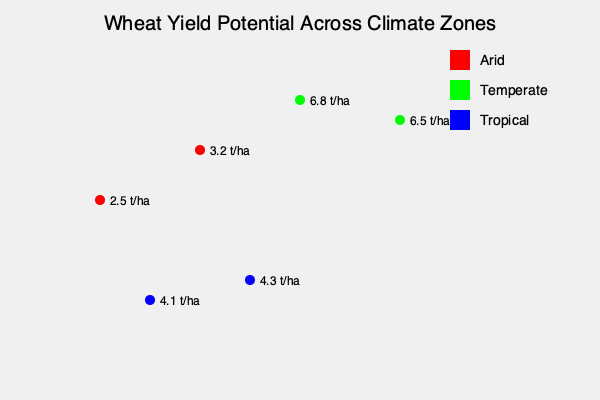Based on the map showing wheat yield potential across different climate zones, which climate zone demonstrates the highest average yield potential, and what factors might contribute to this difference? To answer this question, we need to follow these steps:

1. Identify the climate zones and their respective yield potentials:
   - Arid (red): 2.5 t/ha and 3.2 t/ha
   - Temperate (green): 6.8 t/ha and 6.5 t/ha
   - Tropical (blue): 4.1 t/ha and 4.3 t/ha

2. Calculate the average yield potential for each climate zone:
   - Arid: $(2.5 + 3.2) / 2 = 2.85$ t/ha
   - Temperate: $(6.8 + 6.5) / 2 = 6.65$ t/ha
   - Tropical: $(4.1 + 4.3) / 2 = 4.2$ t/ha

3. Compare the averages to determine the highest yield potential:
   The temperate zone has the highest average yield potential at 6.65 t/ha.

4. Consider factors that might contribute to this difference:
   a) Temperature: Temperate zones have moderate temperatures, which are ideal for wheat growth and development.
   b) Rainfall: Temperate zones often have more consistent and adequate rainfall patterns compared to arid or tropical zones.
   c) Soil quality: Temperate regions often have well-developed, fertile soils suitable for wheat cultivation.
   d) Photoperiod: Wheat varieties adapted to temperate zones may be more responsive to the day length changes in these regions.
   e) Pest and disease pressure: Temperate zones may have lower pest and disease pressure compared to tropical zones.
   f) Agricultural practices: Farmers in temperate zones may have access to more advanced agricultural technologies and practices.

5. Conclusion: The temperate climate zone demonstrates the highest average yield potential due to a combination of favorable environmental conditions and agricultural practices suited for wheat cultivation.
Answer: Temperate zone; favorable temperature, rainfall, soil, photoperiod, lower pest pressure, and advanced agricultural practices. 